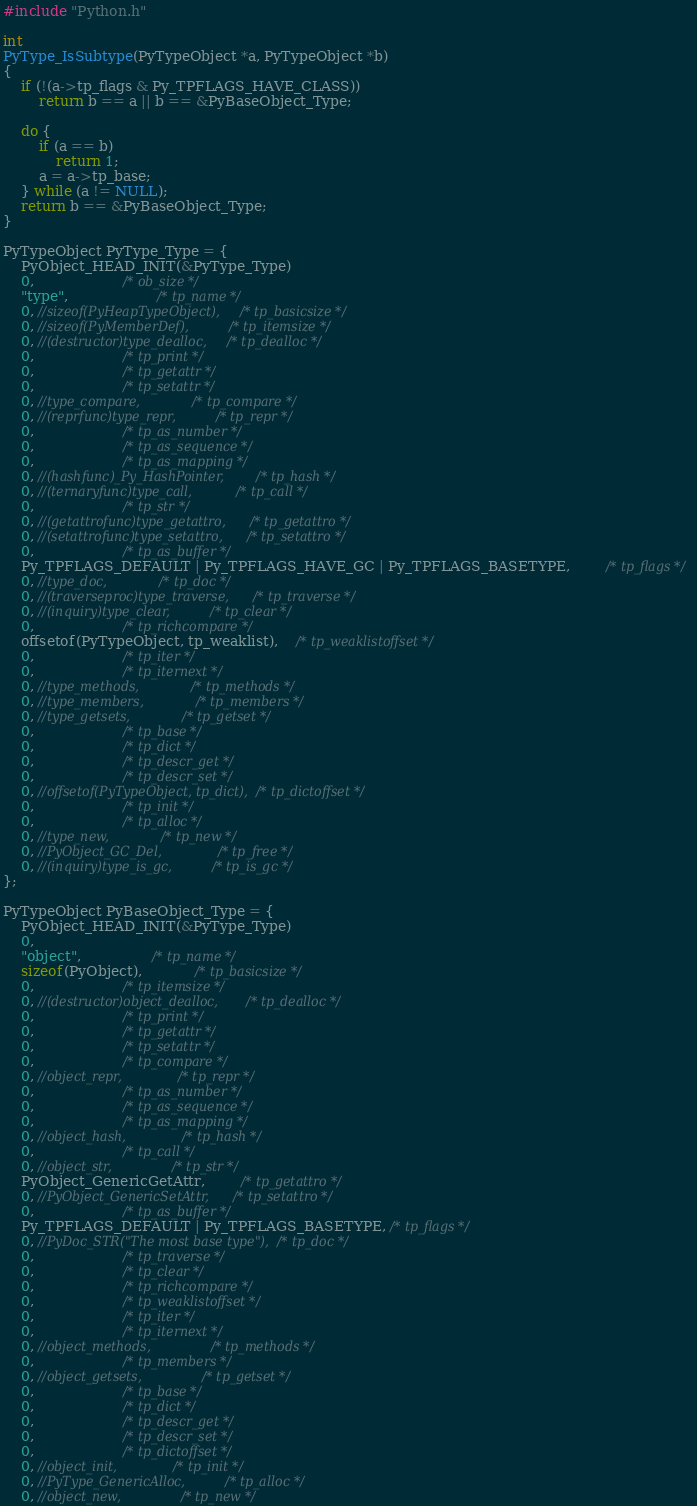<code> <loc_0><loc_0><loc_500><loc_500><_C_>#include "Python.h"

int
PyType_IsSubtype(PyTypeObject *a, PyTypeObject *b)
{
	if (!(a->tp_flags & Py_TPFLAGS_HAVE_CLASS))
		return b == a || b == &PyBaseObject_Type;

	do {
		if (a == b)
			return 1;
		a = a->tp_base;
	} while (a != NULL);
	return b == &PyBaseObject_Type;
}	

PyTypeObject PyType_Type = {
	PyObject_HEAD_INIT(&PyType_Type)
	0,					/* ob_size */
	"type",					/* tp_name */
	0, //sizeof(PyHeapTypeObject),		/* tp_basicsize */
	0, //sizeof(PyMemberDef),			/* tp_itemsize */
	0, //(destructor)type_dealloc,		/* tp_dealloc */
	0,					/* tp_print */
	0,			 		/* tp_getattr */
	0,					/* tp_setattr */
	0, //type_compare,				/* tp_compare */
	0, //(reprfunc)type_repr,			/* tp_repr */
	0,					/* tp_as_number */
	0,					/* tp_as_sequence */
	0,					/* tp_as_mapping */
	0, //(hashfunc)_Py_HashPointer,		/* tp_hash */
	0, //(ternaryfunc)type_call,			/* tp_call */
	0,					/* tp_str */
	0, //(getattrofunc)type_getattro,		/* tp_getattro */
	0, //(setattrofunc)type_setattro,		/* tp_setattro */
	0,					/* tp_as_buffer */
	Py_TPFLAGS_DEFAULT | Py_TPFLAGS_HAVE_GC | Py_TPFLAGS_BASETYPE,		/* tp_flags */
	0, //type_doc,				/* tp_doc */
	0, //(traverseproc)type_traverse,		/* tp_traverse */
	0, //(inquiry)type_clear,			/* tp_clear */
	0,					/* tp_richcompare */
	offsetof(PyTypeObject, tp_weaklist),	/* tp_weaklistoffset */
	0,					/* tp_iter */
	0,					/* tp_iternext */
	0, //type_methods,				/* tp_methods */
	0, //type_members,				/* tp_members */
	0, //type_getsets,				/* tp_getset */
	0,					/* tp_base */
	0,					/* tp_dict */
	0,					/* tp_descr_get */
	0,					/* tp_descr_set */
	0, //offsetof(PyTypeObject, tp_dict),	/* tp_dictoffset */
	0,					/* tp_init */
	0,					/* tp_alloc */
	0, //type_new,				/* tp_new */
	0, //PyObject_GC_Del,        		/* tp_free */
	0, //(inquiry)type_is_gc,			/* tp_is_gc */
};

PyTypeObject PyBaseObject_Type = {
	PyObject_HEAD_INIT(&PyType_Type)
	0,
	"object",				/* tp_name */
	sizeof(PyObject),			/* tp_basicsize */
	0,					/* tp_itemsize */
	0, //(destructor)object_dealloc,		/* tp_dealloc */
	0,					/* tp_print */
	0,			 		/* tp_getattr */
	0,					/* tp_setattr */
	0,					/* tp_compare */
	0, //object_repr,				/* tp_repr */
	0,					/* tp_as_number */
	0,					/* tp_as_sequence */
	0,					/* tp_as_mapping */
	0, //object_hash,				/* tp_hash */
	0,					/* tp_call */
	0, //object_str,				/* tp_str */
	PyObject_GenericGetAttr,		/* tp_getattro */
	0, //PyObject_GenericSetAttr,		/* tp_setattro */
	0,					/* tp_as_buffer */
	Py_TPFLAGS_DEFAULT | Py_TPFLAGS_BASETYPE, /* tp_flags */
	0, //PyDoc_STR("The most base type"),	/* tp_doc */
	0,					/* tp_traverse */
	0,					/* tp_clear */
	0,					/* tp_richcompare */
	0,					/* tp_weaklistoffset */
	0,					/* tp_iter */
	0,					/* tp_iternext */
	0, //object_methods,				/* tp_methods */
	0,					/* tp_members */
	0, //object_getsets,				/* tp_getset */
	0,					/* tp_base */
	0,					/* tp_dict */
	0,					/* tp_descr_get */
	0,					/* tp_descr_set */
	0,					/* tp_dictoffset */
	0, //object_init,				/* tp_init */
	0, //PyType_GenericAlloc,			/* tp_alloc */
	0, //object_new,				/* tp_new */</code> 